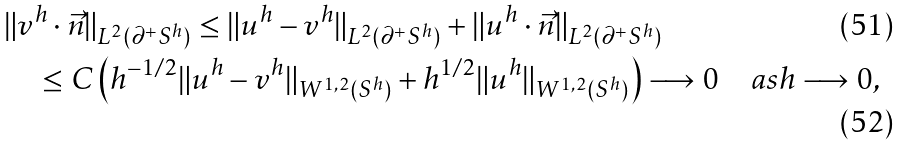<formula> <loc_0><loc_0><loc_500><loc_500>& \| v ^ { h } \cdot \vec { n } \| _ { L ^ { 2 } ( \partial ^ { + } S ^ { h } ) } \leq \| u ^ { h } - v ^ { h } \| _ { L ^ { 2 } ( \partial ^ { + } S ^ { h } ) } + \| u ^ { h } \cdot \vec { n } \| _ { L ^ { 2 } ( \partial ^ { + } S ^ { h } ) } \\ & \quad \leq C \left ( h ^ { - 1 / 2 } \| u ^ { h } - v ^ { h } \| _ { W ^ { 1 , 2 } ( S ^ { h } ) } + h ^ { 1 / 2 } \| u ^ { h } \| _ { W ^ { 1 , 2 } ( S ^ { h } ) } \right ) \longrightarrow 0 \quad a s h \longrightarrow 0 ,</formula> 